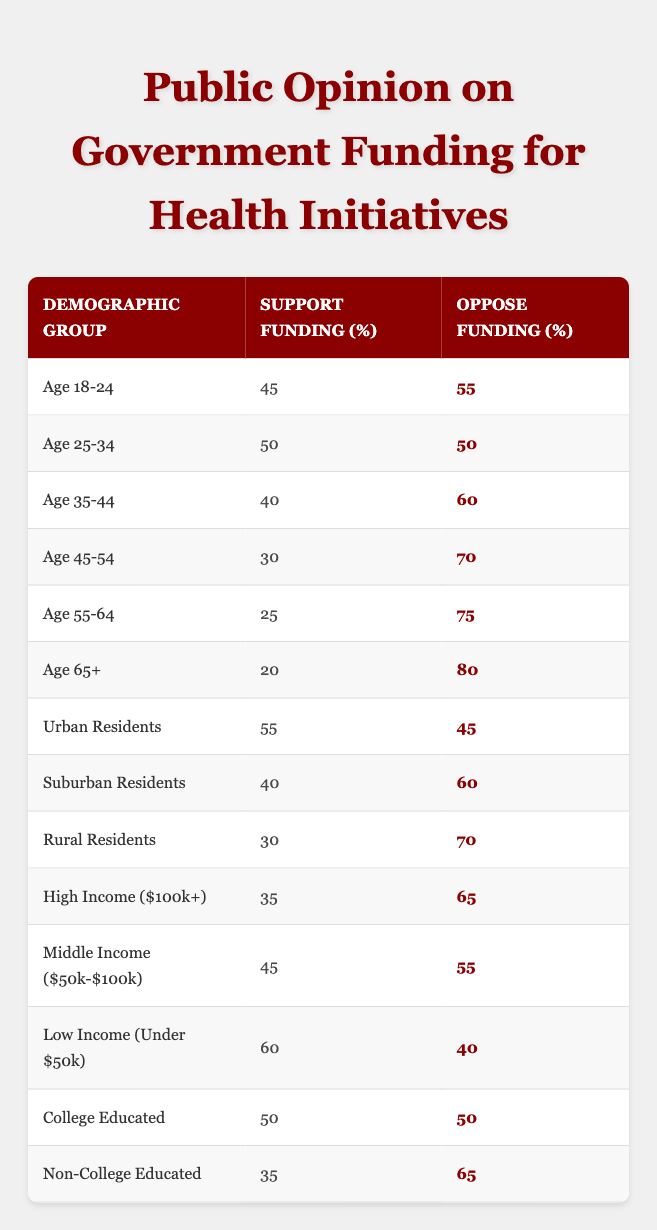What percentage of rural residents support funding? By looking at the row for "Rural Residents," we see that the percentage supporting funding is displayed as 30% in the Support Funding column.
Answer: 30% Which demographic group has the highest percentage opposing funding? Examining the Oppose Funding column, "Age 65+" has the highest percentage at 80%, which is the maximum value in that column.
Answer: Age 65+ What is the difference in support for funding between low-income and high-income groups? The support for low-income is 60% and for high-income is 35%. The difference is calculated as 60 - 35 = 25.
Answer: 25% Is there a higher percentage of support for funding among urban residents compared to suburban residents? Looking at the table, urban residents support funding at 55%, while suburban residents have 40%. Since 55 is greater than 40, the answer is yes.
Answer: Yes What is the average support percentage for funding across all age groups? Adding the support percentages of all age groups: 45 + 50 + 40 + 30 + 25 + 20 = 210. There are 6 age groups, so the average is 210 / 6 = 35.
Answer: 35 How many demographic groups have more than 50% opposition to funding? Looking at the Oppose Funding column, we count the groups with percentages above 50%, which are Age 35-44, Age 45-54, Age 55-64, Age 65+, Suburban Residents, High Income, and Non-College Educated. In total, there are 7 groups.
Answer: 7 Are there more college-educated individuals in support of funding compared to those who are non-college educated? The percentage of college-educated individuals supporting is 50%, while non-college educated support at 35%. Since 50 is greater than 35, the answer is yes.
Answer: Yes What is the percentage difference in opposition to funding between the age group 18-24 and those in the rural demographic? The percentage opposing funding for age 18-24 is 55% and for rural residents is 70%. The difference is 70 - 55 = 15.
Answer: 15 Which income group has the lowest support for funding? Observing the Support Funding percentages, "Age 65+" shows the lowest support at 20%, making it the lowest among all groups listed.
Answer: Age 65+ 